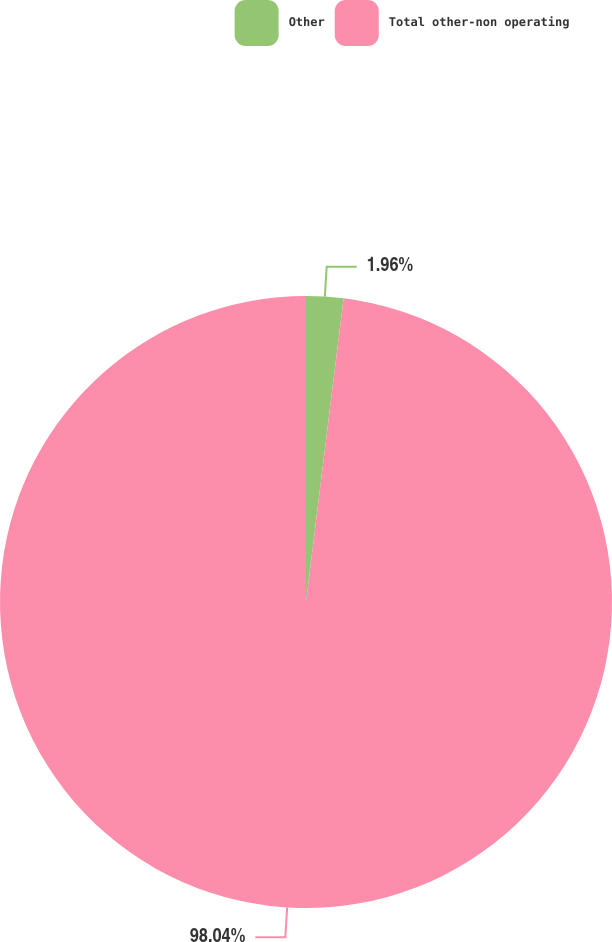Convert chart. <chart><loc_0><loc_0><loc_500><loc_500><pie_chart><fcel>Other<fcel>Total other-non operating<nl><fcel>1.96%<fcel>98.04%<nl></chart> 